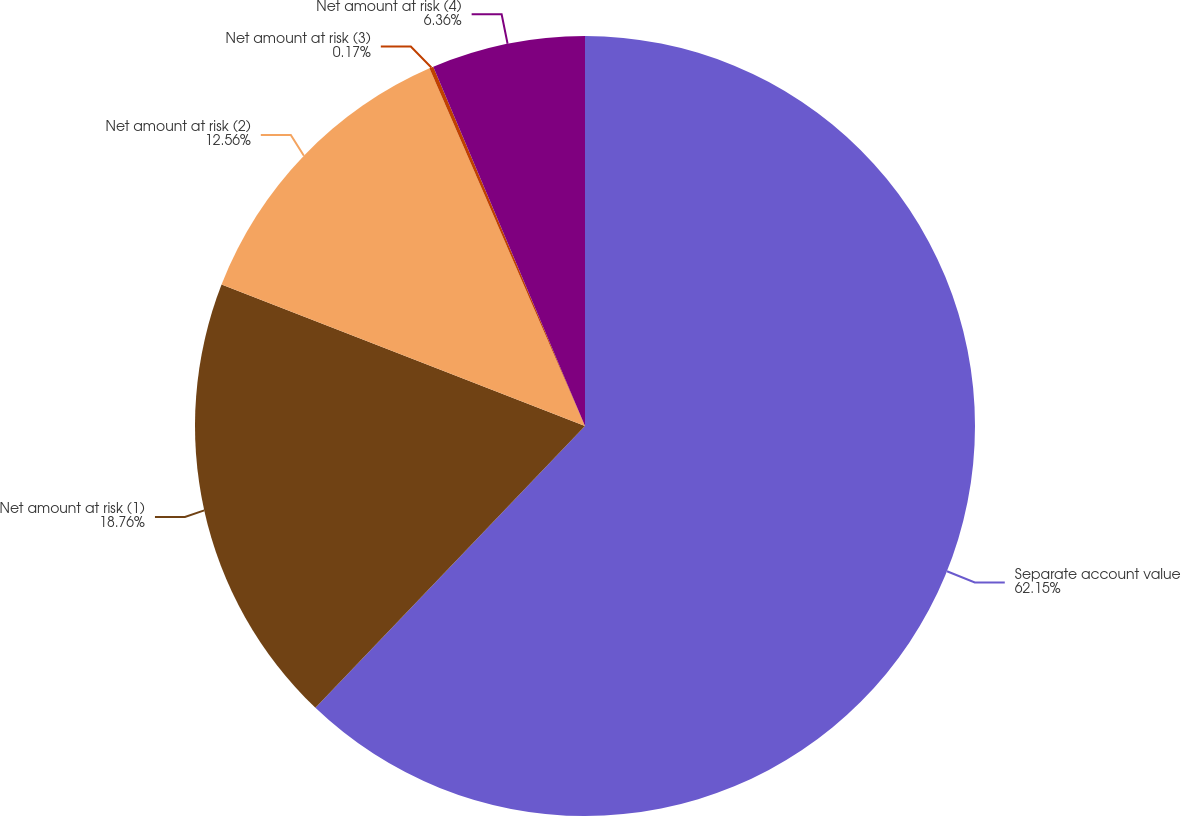Convert chart. <chart><loc_0><loc_0><loc_500><loc_500><pie_chart><fcel>Separate account value<fcel>Net amount at risk (1)<fcel>Net amount at risk (2)<fcel>Net amount at risk (3)<fcel>Net amount at risk (4)<nl><fcel>62.14%<fcel>18.76%<fcel>12.56%<fcel>0.17%<fcel>6.36%<nl></chart> 